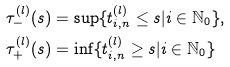Convert formula to latex. <formula><loc_0><loc_0><loc_500><loc_500>& \tau _ { - } ^ { ( l ) } ( s ) = \sup \{ t _ { i , n } ^ { ( l ) } \leq s | i \in \mathbb { N } _ { 0 } \} , \\ & \tau _ { + } ^ { ( l ) } ( s ) = \inf \{ t _ { i , n } ^ { ( l ) } \geq s | i \in \mathbb { N } _ { 0 } \}</formula> 